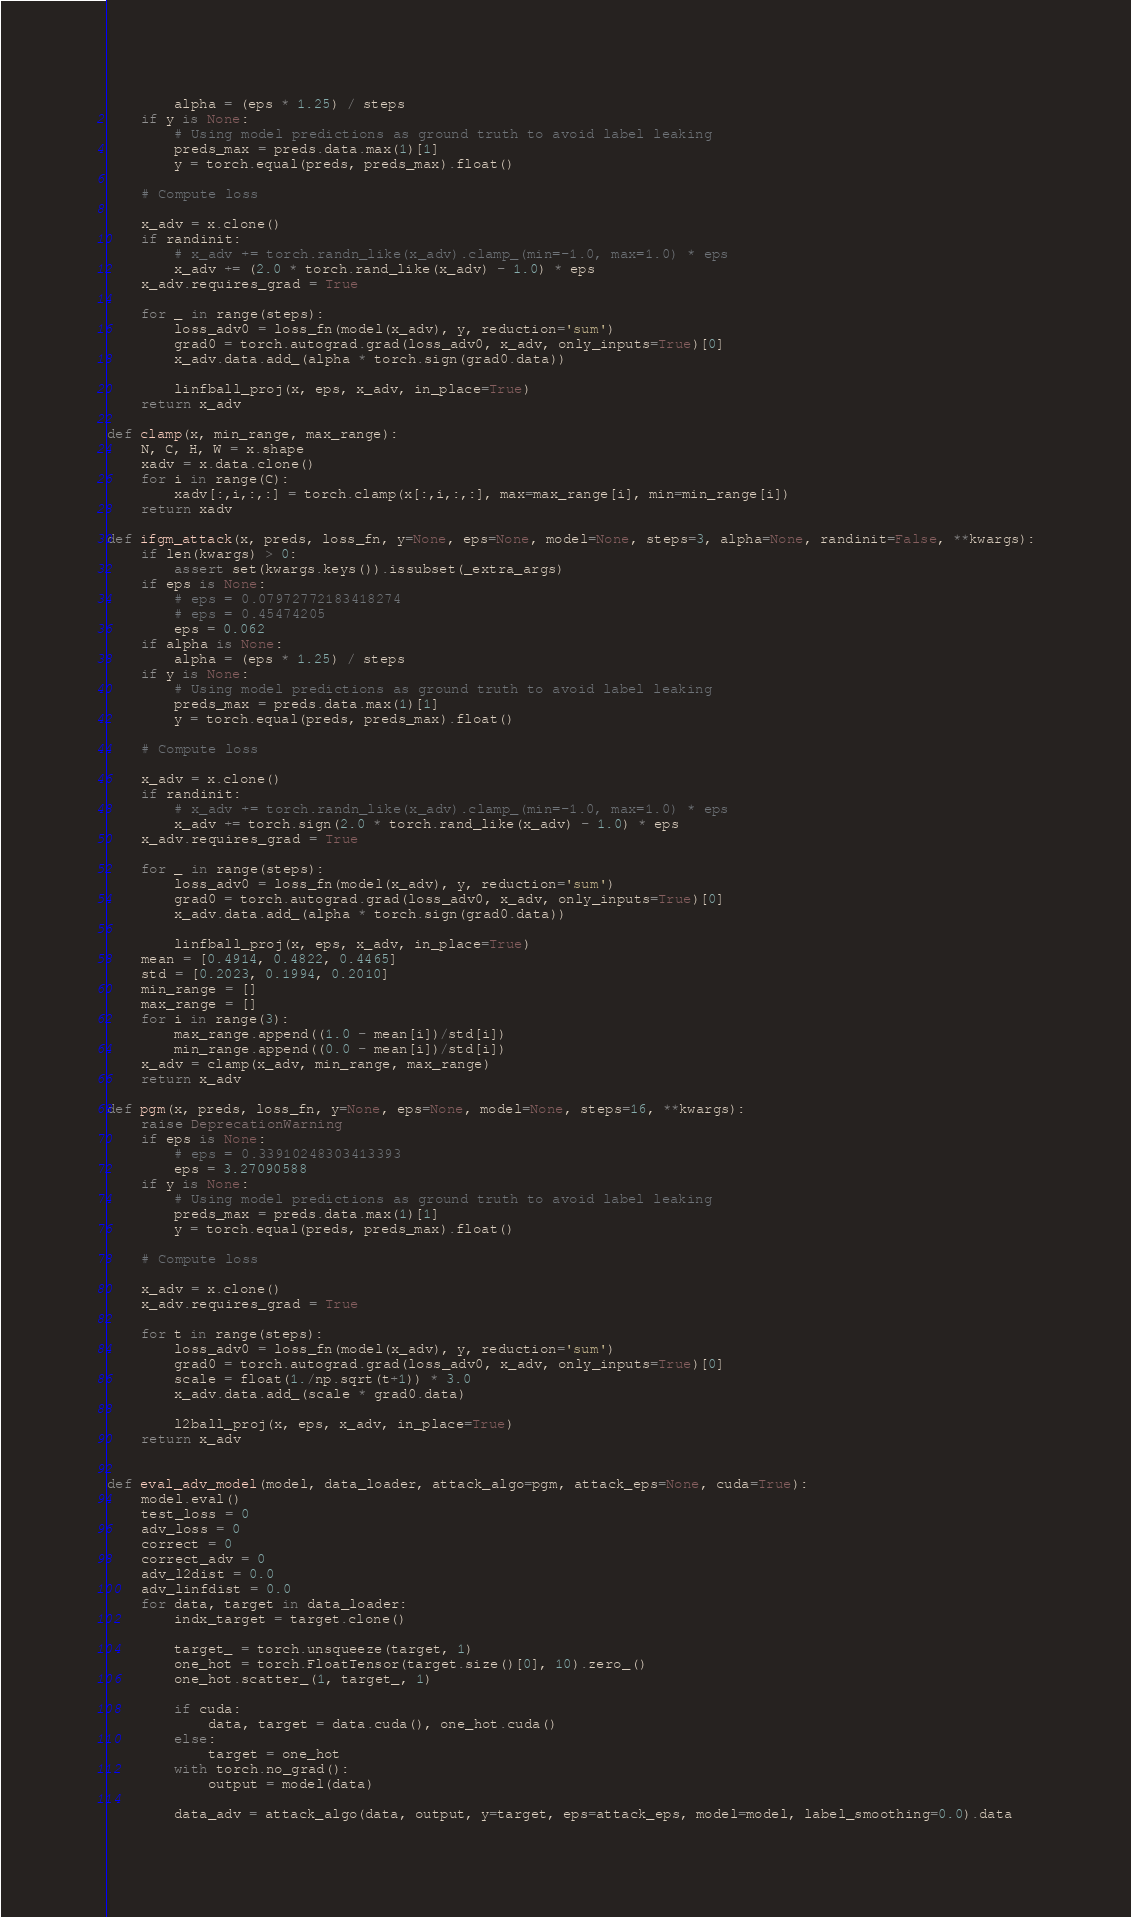<code> <loc_0><loc_0><loc_500><loc_500><_Python_>        alpha = (eps * 1.25) / steps
    if y is None:
        # Using model predictions as ground truth to avoid label leaking
        preds_max = preds.data.max(1)[1]
        y = torch.equal(preds, preds_max).float()

    # Compute loss

    x_adv = x.clone()
    if randinit:
        # x_adv += torch.randn_like(x_adv).clamp_(min=-1.0, max=1.0) * eps
        x_adv += (2.0 * torch.rand_like(x_adv) - 1.0) * eps
    x_adv.requires_grad = True

    for _ in range(steps):
        loss_adv0 = loss_fn(model(x_adv), y, reduction='sum')
        grad0 = torch.autograd.grad(loss_adv0, x_adv, only_inputs=True)[0]
        x_adv.data.add_(alpha * torch.sign(grad0.data))

        linfball_proj(x, eps, x_adv, in_place=True)
    return x_adv

def clamp(x, min_range, max_range):
    N, C, H, W = x.shape
    xadv = x.data.clone()
    for i in range(C):
        xadv[:,i,:,:] = torch.clamp(x[:,i,:,:], max=max_range[i], min=min_range[i])
    return xadv

def ifgm_attack(x, preds, loss_fn, y=None, eps=None, model=None, steps=3, alpha=None, randinit=False, **kwargs):
    if len(kwargs) > 0:
        assert set(kwargs.keys()).issubset(_extra_args)
    if eps is None:
        # eps = 0.07972772183418274
        # eps = 0.45474205
        eps = 0.062
    if alpha is None:
        alpha = (eps * 1.25) / steps
    if y is None:
        # Using model predictions as ground truth to avoid label leaking
        preds_max = preds.data.max(1)[1]
        y = torch.equal(preds, preds_max).float()

    # Compute loss

    x_adv = x.clone()
    if randinit:
        # x_adv += torch.randn_like(x_adv).clamp_(min=-1.0, max=1.0) * eps
        x_adv += torch.sign(2.0 * torch.rand_like(x_adv) - 1.0) * eps
    x_adv.requires_grad = True

    for _ in range(steps):
        loss_adv0 = loss_fn(model(x_adv), y, reduction='sum')
        grad0 = torch.autograd.grad(loss_adv0, x_adv, only_inputs=True)[0]
        x_adv.data.add_(alpha * torch.sign(grad0.data))

        linfball_proj(x, eps, x_adv, in_place=True)
    mean = [0.4914, 0.4822, 0.4465]
    std = [0.2023, 0.1994, 0.2010]
    min_range = []
    max_range = []
    for i in range(3):
        max_range.append((1.0 - mean[i])/std[i])
        min_range.append((0.0 - mean[i])/std[i])
    x_adv = clamp(x_adv, min_range, max_range)
    return x_adv

def pgm(x, preds, loss_fn, y=None, eps=None, model=None, steps=16, **kwargs):
    raise DeprecationWarning
    if eps is None:
        # eps = 0.33910248303413393
        eps = 3.27090588
    if y is None:
        # Using model predictions as ground truth to avoid label leaking
        preds_max = preds.data.max(1)[1]
        y = torch.equal(preds, preds_max).float()

    # Compute loss

    x_adv = x.clone()
    x_adv.requires_grad = True

    for t in range(steps):
        loss_adv0 = loss_fn(model(x_adv), y, reduction='sum')
        grad0 = torch.autograd.grad(loss_adv0, x_adv, only_inputs=True)[0]
        scale = float(1./np.sqrt(t+1)) * 3.0
        x_adv.data.add_(scale * grad0.data)

        l2ball_proj(x, eps, x_adv, in_place=True)
    return x_adv


def eval_adv_model(model, data_loader, attack_algo=pgm, attack_eps=None, cuda=True):
    model.eval()
    test_loss = 0
    adv_loss = 0
    correct = 0
    correct_adv = 0
    adv_l2dist = 0.0
    adv_linfdist = 0.0
    for data, target in data_loader:
        indx_target = target.clone()

        target_ = torch.unsqueeze(target, 1)
        one_hot = torch.FloatTensor(target.size()[0], 10).zero_()
        one_hot.scatter_(1, target_, 1)

        if cuda:
            data, target = data.cuda(), one_hot.cuda()
        else:
            target = one_hot
        with torch.no_grad():
            output = model(data)

        data_adv = attack_algo(data, output, y=target, eps=attack_eps, model=model, label_smoothing=0.0).data</code> 